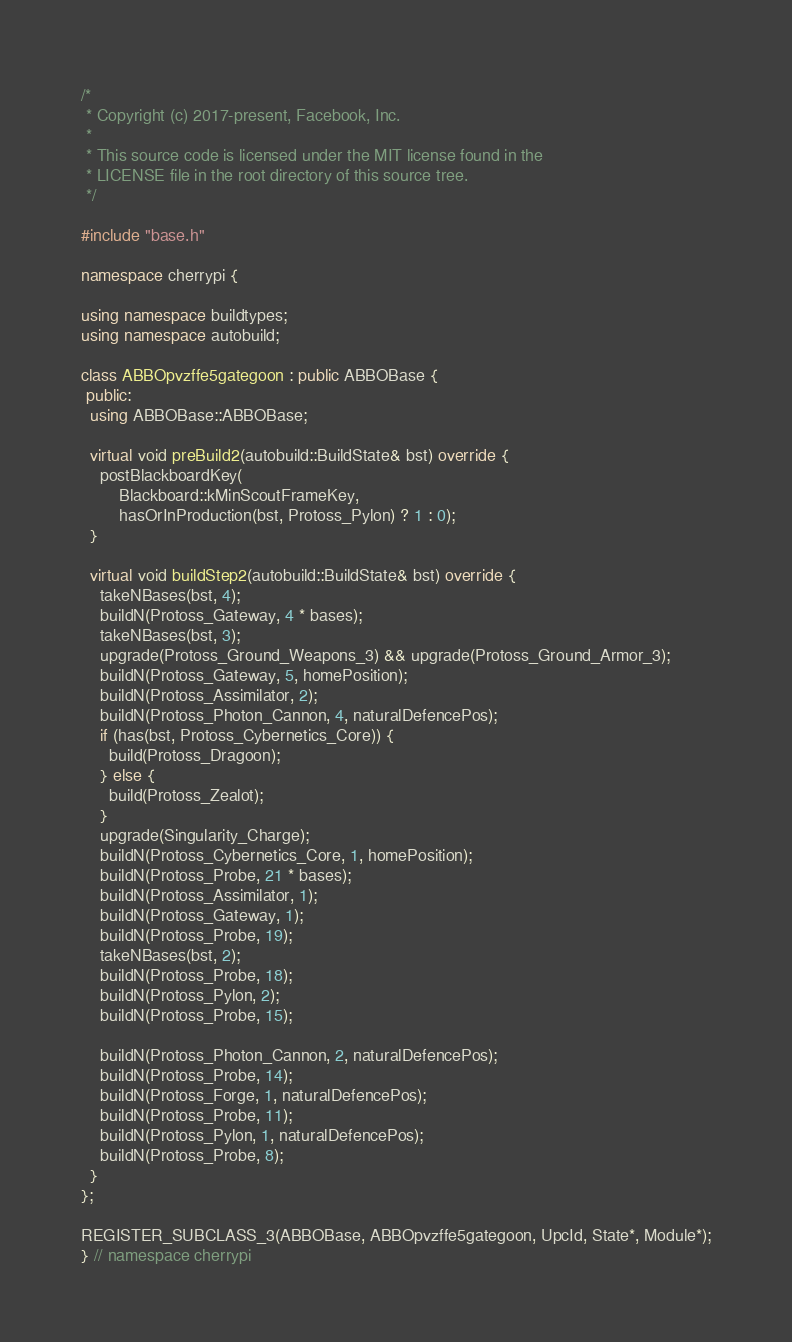<code> <loc_0><loc_0><loc_500><loc_500><_C++_>/*
 * Copyright (c) 2017-present, Facebook, Inc.
 *
 * This source code is licensed under the MIT license found in the
 * LICENSE file in the root directory of this source tree.
 */

#include "base.h"

namespace cherrypi {

using namespace buildtypes;
using namespace autobuild;

class ABBOpvzffe5gategoon : public ABBOBase {
 public:
  using ABBOBase::ABBOBase;

  virtual void preBuild2(autobuild::BuildState& bst) override {
    postBlackboardKey(
        Blackboard::kMinScoutFrameKey,
        hasOrInProduction(bst, Protoss_Pylon) ? 1 : 0);
  }

  virtual void buildStep2(autobuild::BuildState& bst) override {
    takeNBases(bst, 4);
    buildN(Protoss_Gateway, 4 * bases);
    takeNBases(bst, 3);
    upgrade(Protoss_Ground_Weapons_3) && upgrade(Protoss_Ground_Armor_3);
    buildN(Protoss_Gateway, 5, homePosition);
    buildN(Protoss_Assimilator, 2);
    buildN(Protoss_Photon_Cannon, 4, naturalDefencePos);
    if (has(bst, Protoss_Cybernetics_Core)) {
      build(Protoss_Dragoon);
    } else {
      build(Protoss_Zealot);
    }
    upgrade(Singularity_Charge);
    buildN(Protoss_Cybernetics_Core, 1, homePosition);
    buildN(Protoss_Probe, 21 * bases);
    buildN(Protoss_Assimilator, 1);
    buildN(Protoss_Gateway, 1);
    buildN(Protoss_Probe, 19);
    takeNBases(bst, 2);
    buildN(Protoss_Probe, 18);
    buildN(Protoss_Pylon, 2);
    buildN(Protoss_Probe, 15);

    buildN(Protoss_Photon_Cannon, 2, naturalDefencePos);
    buildN(Protoss_Probe, 14);
    buildN(Protoss_Forge, 1, naturalDefencePos);
    buildN(Protoss_Probe, 11);
    buildN(Protoss_Pylon, 1, naturalDefencePos);
    buildN(Protoss_Probe, 8);
  }
};

REGISTER_SUBCLASS_3(ABBOBase, ABBOpvzffe5gategoon, UpcId, State*, Module*);
} // namespace cherrypi
</code> 